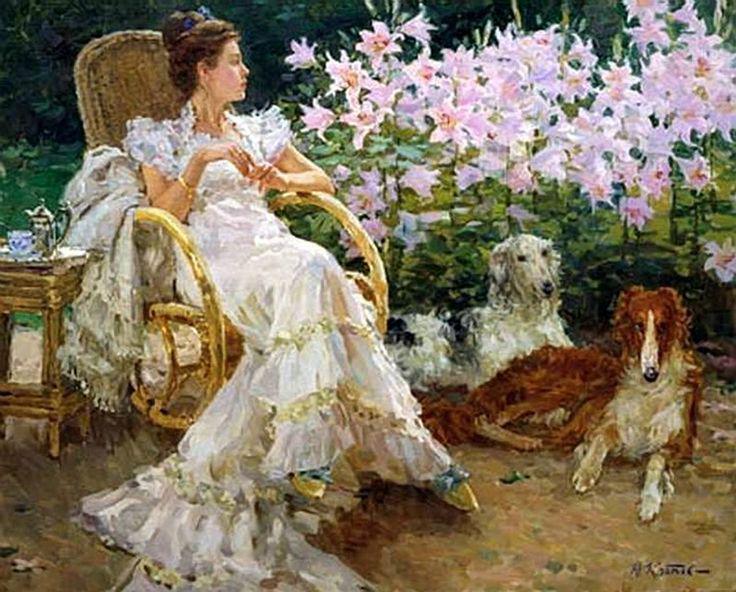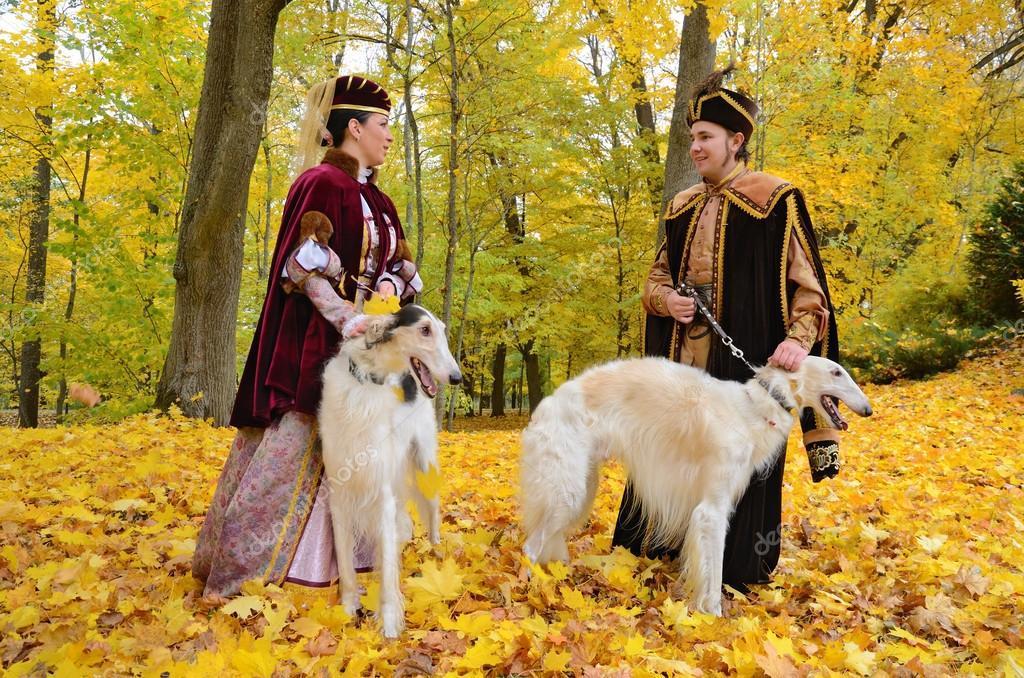The first image is the image on the left, the second image is the image on the right. Examine the images to the left and right. Is the description "A woman is sitting with her two dogs." accurate? Answer yes or no. Yes. The first image is the image on the left, the second image is the image on the right. For the images shown, is this caption "A woman is sitting with her two dogs nearby." true? Answer yes or no. Yes. 